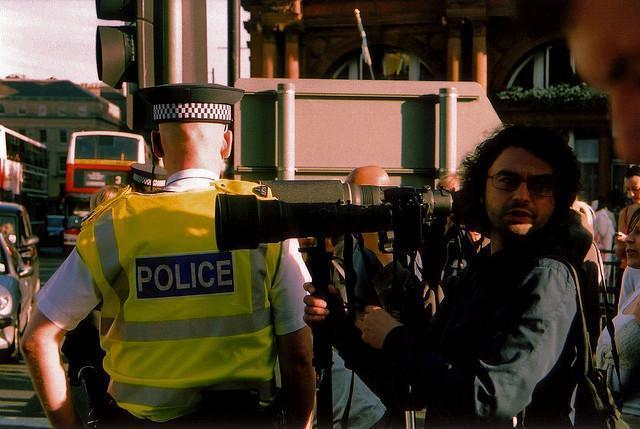How many buses are there?
Give a very brief answer. 2. How many people are there?
Give a very brief answer. 4. How many people have remotes in their hands?
Give a very brief answer. 0. 